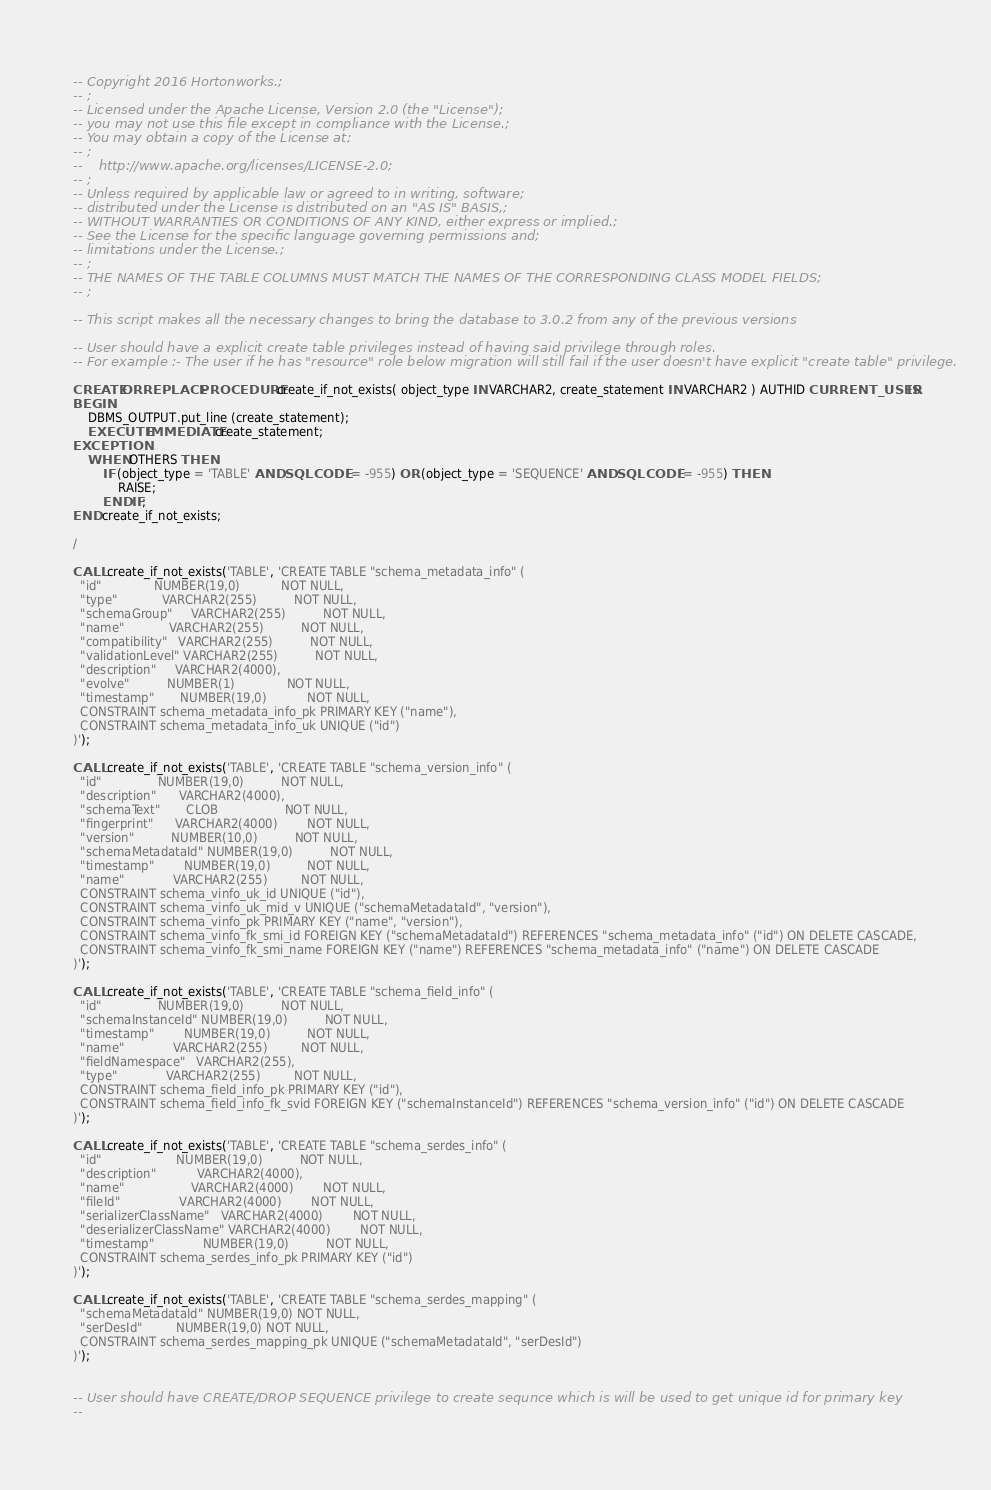Convert code to text. <code><loc_0><loc_0><loc_500><loc_500><_SQL_>-- Copyright 2016 Hortonworks.;
-- ;
-- Licensed under the Apache License, Version 2.0 (the "License");
-- you may not use this file except in compliance with the License.;
-- You may obtain a copy of the License at;
-- ;
--    http://www.apache.org/licenses/LICENSE-2.0;
-- ;
-- Unless required by applicable law or agreed to in writing, software;
-- distributed under the License is distributed on an "AS IS" BASIS,;
-- WITHOUT WARRANTIES OR CONDITIONS OF ANY KIND, either express or implied.;
-- See the License for the specific language governing permissions and;
-- limitations under the License.;
-- ;
-- THE NAMES OF THE TABLE COLUMNS MUST MATCH THE NAMES OF THE CORRESPONDING CLASS MODEL FIELDS;
-- ;

-- This script makes all the necessary changes to bring the database to 3.0.2 from any of the previous versions

-- User should have a explicit create table privileges instead of having said privilege through roles.
-- For example :- The user if he has "resource" role below migration will still fail if the user doesn't have explicit "create table" privilege.

CREATE OR REPLACE PROCEDURE create_if_not_exists( object_type IN VARCHAR2, create_statement IN VARCHAR2 ) AUTHID CURRENT_USER IS
BEGIN
    DBMS_OUTPUT.put_line (create_statement);
    EXECUTE IMMEDIATE create_statement;
EXCEPTION
    WHEN OTHERS THEN
        IF (object_type = 'TABLE' AND SQLCODE != -955) OR (object_type = 'SEQUENCE' AND SQLCODE != -955) THEN
            RAISE;
        END IF;
END create_if_not_exists;

/

CALL create_if_not_exists('TABLE', 'CREATE TABLE "schema_metadata_info" (
  "id"              NUMBER(19,0)           NOT NULL,
  "type"            VARCHAR2(255)          NOT NULL,
  "schemaGroup"     VARCHAR2(255)          NOT NULL,
  "name"            VARCHAR2(255)          NOT NULL,
  "compatibility"   VARCHAR2(255)          NOT NULL,
  "validationLevel" VARCHAR2(255)          NOT NULL,
  "description"     VARCHAR2(4000),
  "evolve"          NUMBER(1)              NOT NULL,
  "timestamp"       NUMBER(19,0)           NOT NULL,
  CONSTRAINT schema_metadata_info_pk PRIMARY KEY ("name"),
  CONSTRAINT schema_metadata_info_uk UNIQUE ("id")
)');

CALL create_if_not_exists('TABLE', 'CREATE TABLE "schema_version_info" (
  "id"               NUMBER(19,0)          NOT NULL,
  "description"      VARCHAR2(4000),
  "schemaText"       CLOB                  NOT NULL,
  "fingerprint"      VARCHAR2(4000)        NOT NULL,
  "version"          NUMBER(10,0)          NOT NULL,
  "schemaMetadataId" NUMBER(19,0)          NOT NULL,
  "timestamp"        NUMBER(19,0)          NOT NULL,
  "name"             VARCHAR2(255)         NOT NULL,
  CONSTRAINT schema_vinfo_uk_id UNIQUE ("id"),
  CONSTRAINT schema_vinfo_uk_mid_v UNIQUE ("schemaMetadataId", "version"),
  CONSTRAINT schema_vinfo_pk PRIMARY KEY ("name", "version"),
  CONSTRAINT schema_vinfo_fk_smi_id FOREIGN KEY ("schemaMetadataId") REFERENCES "schema_metadata_info" ("id") ON DELETE CASCADE,
  CONSTRAINT schema_vinfo_fk_smi_name FOREIGN KEY ("name") REFERENCES "schema_metadata_info" ("name") ON DELETE CASCADE
)');

CALL create_if_not_exists('TABLE', 'CREATE TABLE "schema_field_info" (
  "id"               NUMBER(19,0)          NOT NULL,
  "schemaInstanceId" NUMBER(19,0)          NOT NULL,
  "timestamp"        NUMBER(19,0)          NOT NULL,
  "name"             VARCHAR2(255)         NOT NULL,
  "fieldNamespace"   VARCHAR2(255),
  "type"             VARCHAR2(255)         NOT NULL,
  CONSTRAINT schema_field_info_pk PRIMARY KEY ("id"),
  CONSTRAINT schema_field_info_fk_svid FOREIGN KEY ("schemaInstanceId") REFERENCES "schema_version_info" ("id") ON DELETE CASCADE
)');

CALL create_if_not_exists('TABLE', 'CREATE TABLE "schema_serdes_info" (
  "id"                    NUMBER(19,0)          NOT NULL,
  "description"           VARCHAR2(4000),
  "name"                  VARCHAR2(4000)        NOT NULL,
  "fileId"                VARCHAR2(4000)        NOT NULL,
  "serializerClassName"   VARCHAR2(4000)        NOT NULL,
  "deserializerClassName" VARCHAR2(4000)        NOT NULL,
  "timestamp"             NUMBER(19,0)          NOT NULL,
  CONSTRAINT schema_serdes_info_pk PRIMARY KEY ("id")
)');

CALL create_if_not_exists('TABLE', 'CREATE TABLE "schema_serdes_mapping" (
  "schemaMetadataId" NUMBER(19,0) NOT NULL,
  "serDesId"         NUMBER(19,0) NOT NULL,
  CONSTRAINT schema_serdes_mapping_pk UNIQUE ("schemaMetadataId", "serDesId")
)');


-- User should have CREATE/DROP SEQUENCE privilege to create sequnce which is will be used to get unique id for primary key
--</code> 